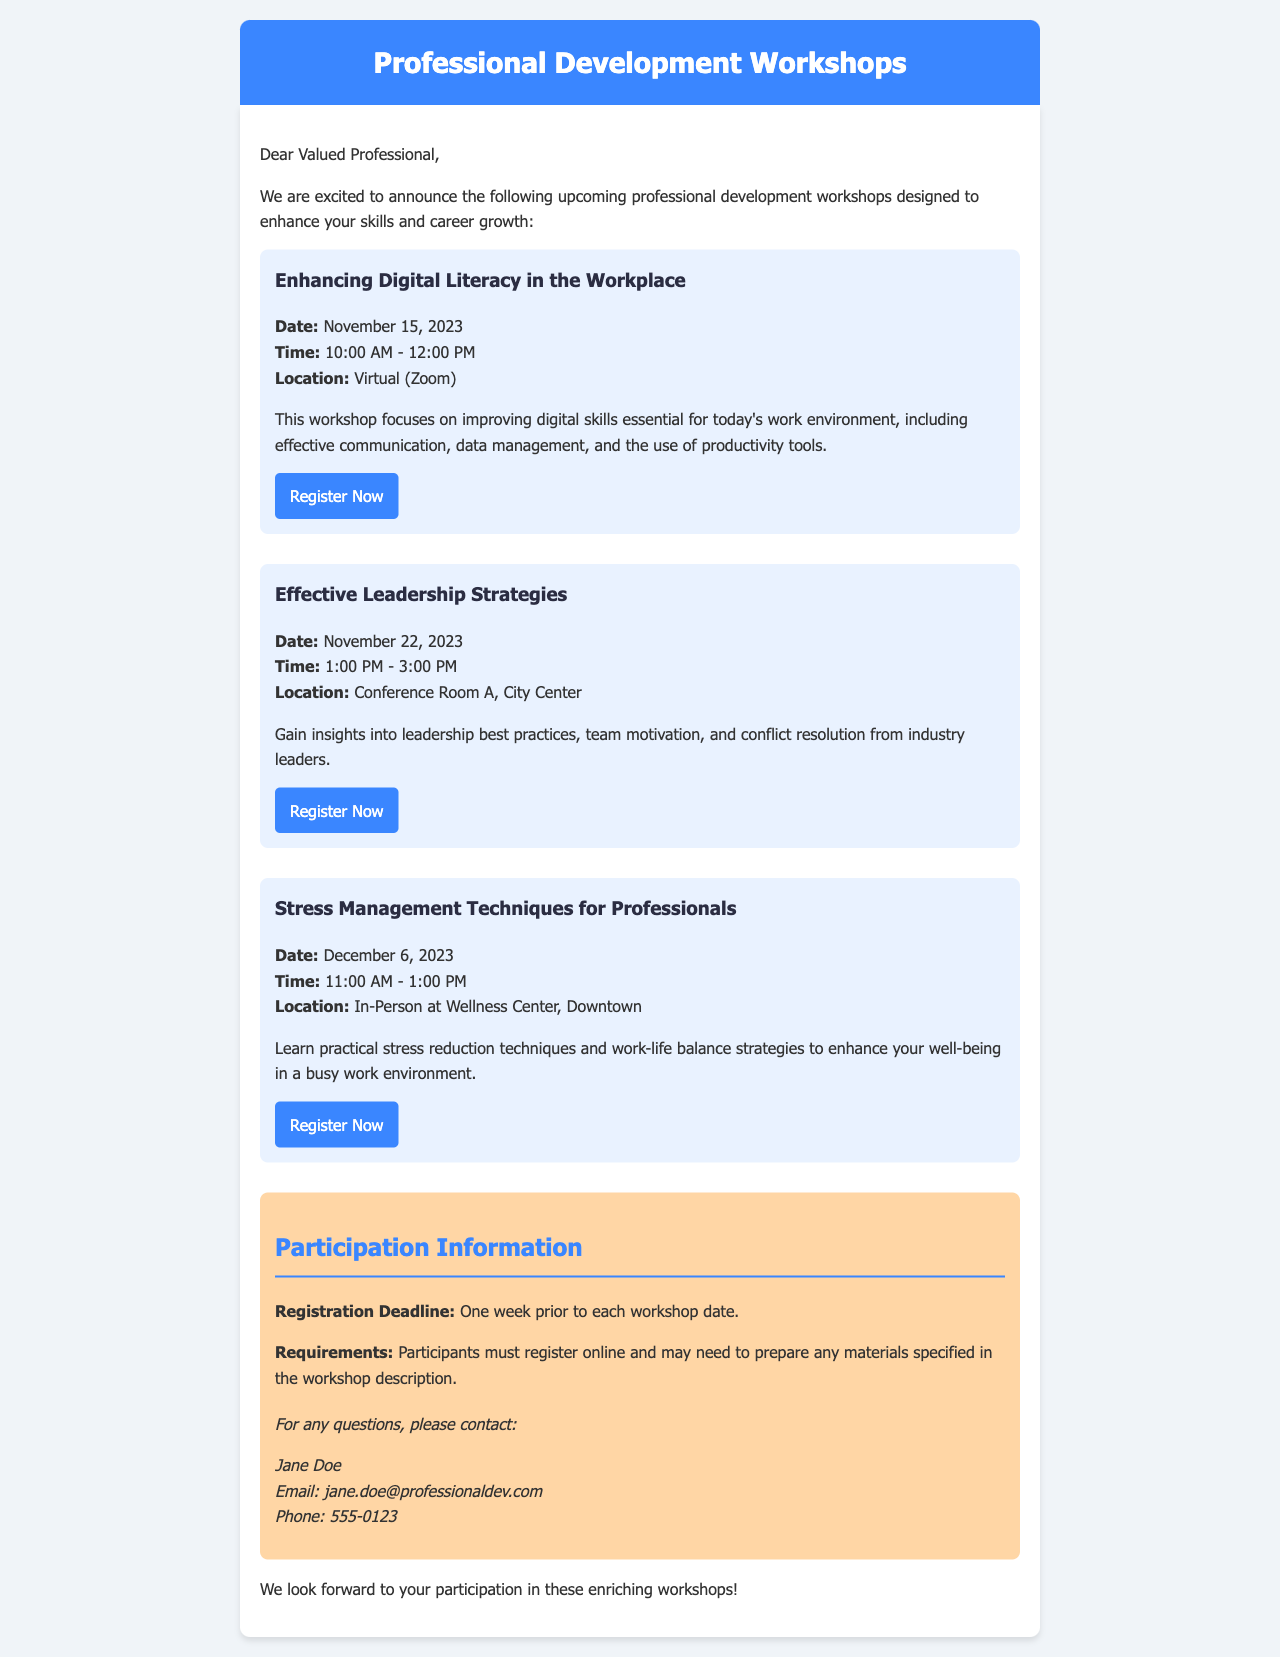What is the date of the first workshop? The first workshop is titled "Enhancing Digital Literacy in the Workplace," and its date is mentioned in the document.
Answer: November 15, 2023 What is the location of the second workshop? The second workshop is "Effective Leadership Strategies," which specifies its location in the document.
Answer: Conference Room A, City Center What time does the stress management workshop start? The document provides the time for the "Stress Management Techniques for Professionals" workshop, allowing for a precise answer.
Answer: 11:00 AM How long is the "Effective Leadership Strategies" workshop? The duration can be inferred by looking at the start and end times listed in the document for this workshop.
Answer: 2 hours When is the registration deadline? The document states a specific deadline for registration relative to each workshop date.
Answer: One week prior to each workshop date What is required for participants to do before the workshops? The document outlines participant requirements regarding registration and preparation for workshops.
Answer: Register online Who is the contact person for questions? The document names the individual for contact regarding inquiries about the workshops.
Answer: Jane Doe What is offered in the stress management workshop? The content of the workshop is summarized in the document, providing insights into what participants will learn.
Answer: Stress reduction techniques Which workshop is focused on digital skills? The document specifies the title of the workshop that aims to improve digital skills in the workplace.
Answer: Enhancing Digital Literacy in the Workplace 